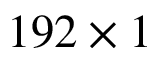Convert formula to latex. <formula><loc_0><loc_0><loc_500><loc_500>1 9 2 \times 1</formula> 